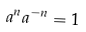Convert formula to latex. <formula><loc_0><loc_0><loc_500><loc_500>a ^ { n } a ^ { - n } = 1</formula> 